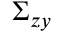<formula> <loc_0><loc_0><loc_500><loc_500>\Sigma _ { z y }</formula> 